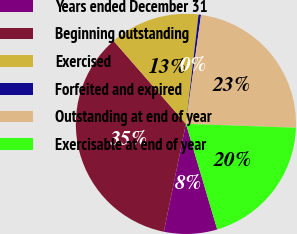Convert chart. <chart><loc_0><loc_0><loc_500><loc_500><pie_chart><fcel>Years ended December 31<fcel>Beginning outstanding<fcel>Exercised<fcel>Forfeited and expired<fcel>Outstanding at end of year<fcel>Exercisable at end of year<nl><fcel>7.81%<fcel>35.38%<fcel>13.24%<fcel>0.36%<fcel>23.36%<fcel>19.86%<nl></chart> 